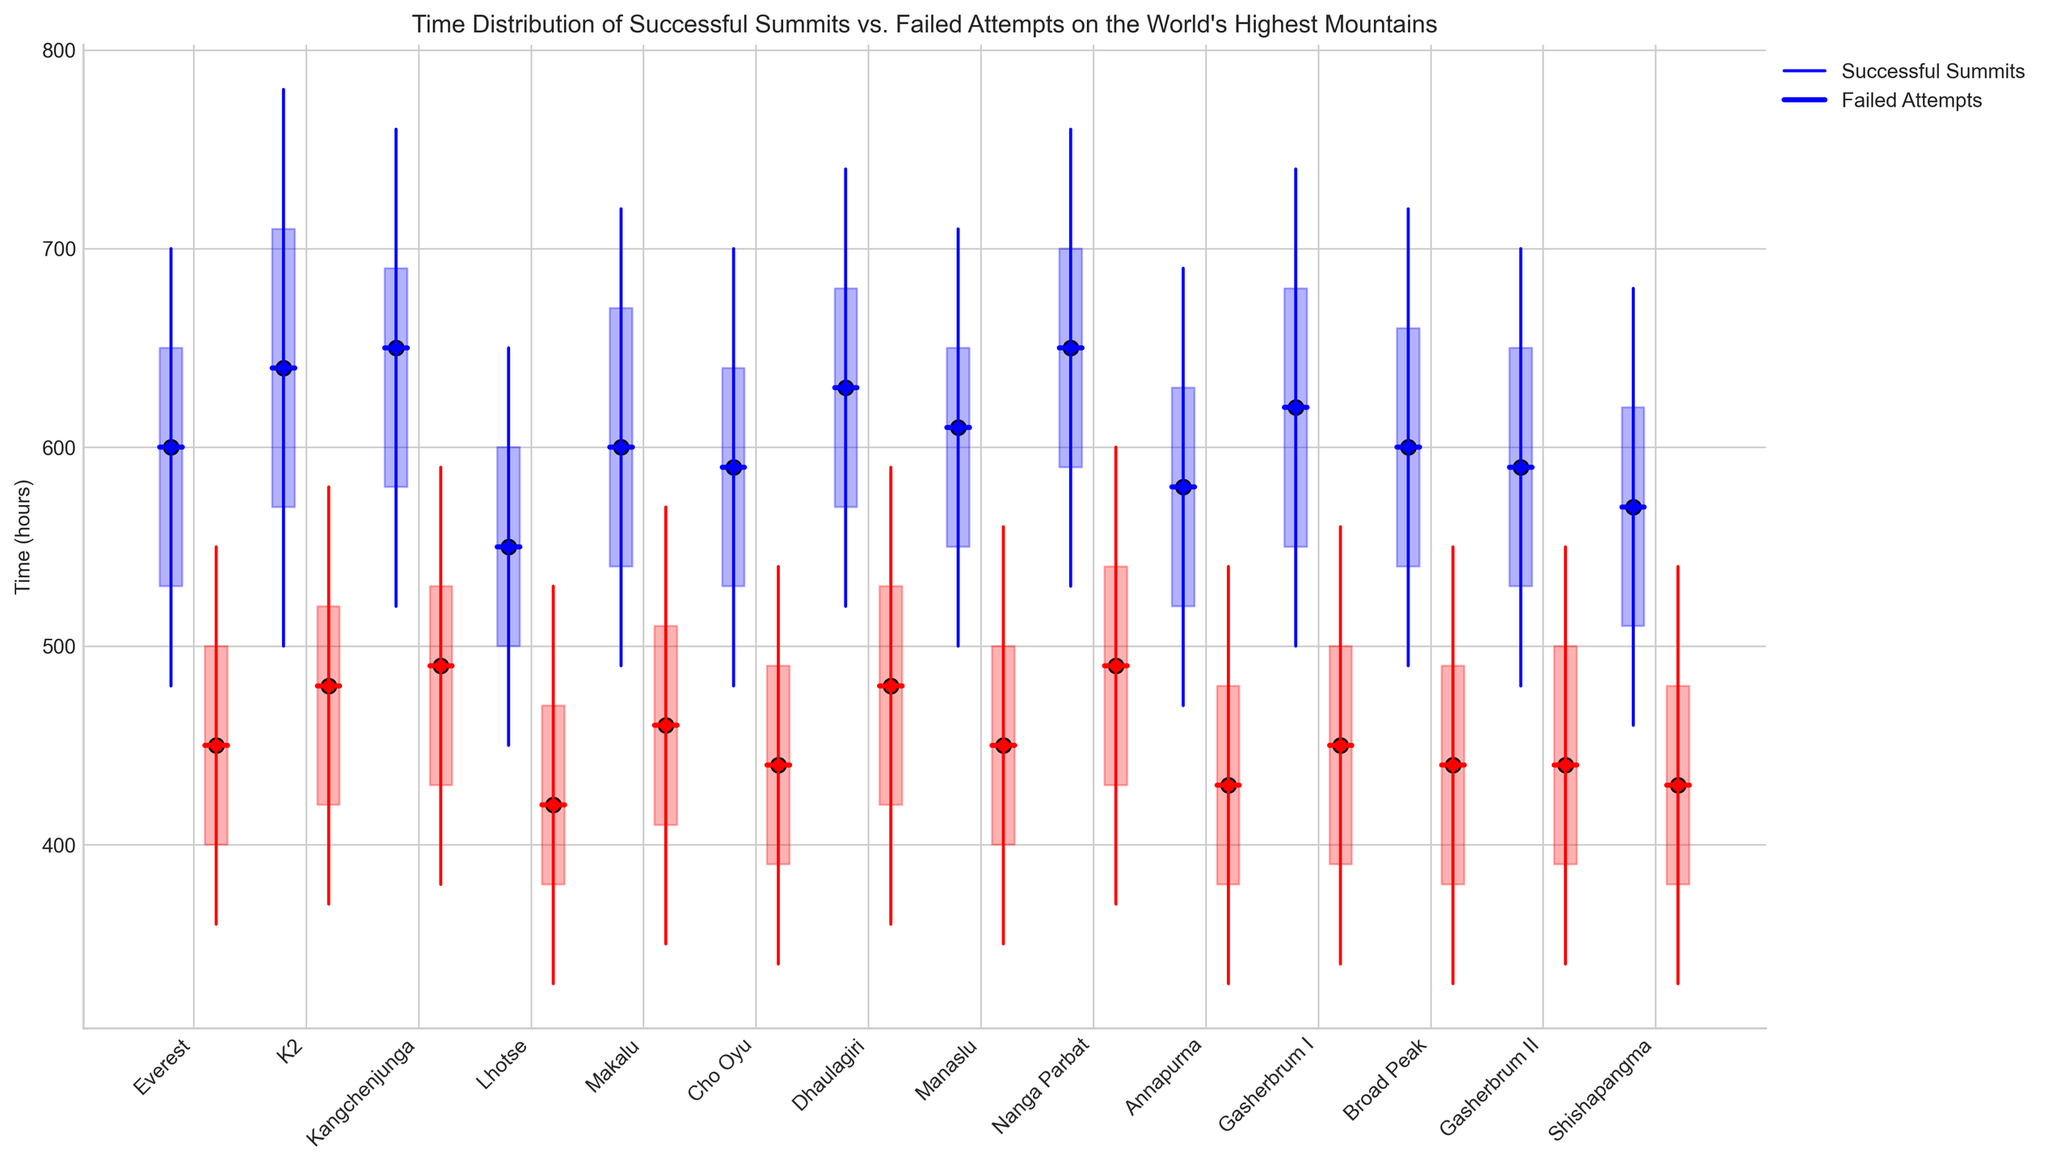How does the median time for successful summits on Everest compare to failed attempts? To compare the medians, look at the point representing the median on the blue line for successful summits and the red line for failed attempts on Everest. The blue median is at 600 hours, and the red median is at 450 hours. The median time for successful summits is greater than that for failed attempts.
Answer: 600 hours vs. 450 hours Which mountain has the smallest difference in median time between successful summits and failed attempts? To find the smallest difference in median times, calculate the differences for each mountain and compare them. For Shishapangma, the difference is minimal: successful (570 hours) and failed (430 hours). The difference is 140 hours, which is the smallest among the given data.
Answer: Shishapangma What is the range of times for failed attempts on Dhaulagiri? The range can be found by subtracting the minimum value from the maximum value for failed attempts. For Dhaulagiri, the minimum is 360 hours and the maximum is 590 hours. The range is 590 - 360 = 230 hours.
Answer: 230 hours For which mountain are the times for successful summits closest in their 25th to 75th percentile range? Examine the blue shaded areas for successful summits and find the smallest range. For Lhotse, the 25th percentile is 500 hours and the 75th percentile is 600 hours. This gives a range of 100 hours, which is the smallest range.
Answer: Lhotse Which mountain has the maximum time for successful summits that is the greatest among all mountains? Look at the highest point on the blue lines for each mountain. For Nanga Parbat and Kangchenjunga, the maximum time for successful summits is at 760 hours. Among these, any one can be considered.
Answer: Nanga Parbat / Kangchenjunga How much greater is the median time for successful summits on Makalu compared to Shishapangma? Calculate the difference between the median times. For Makalu, the median time is 600 hours, and for Shishapangma, it is 570 hours. The difference is 600 - 570 = 30 hours.
Answer: 30 hours Which mountain shows the widest spread (difference between max and min) for successful summits? Examine the blue lines for the maximum and minimum values and find the mountain with the widest spread. For K2, the range is from 500 to 780 hours, making the spread 280 hours, the widest among all.
Answer: K2 Which mountain has the lowest 25th percentile time for failed attempts? Look at the bottom of the red shaded areas and find the lowest 25th percentile value. For Annapurna, the 25th percentile time is 380 hours. This is the lowest among the given mountains.
Answer: Annapurna 